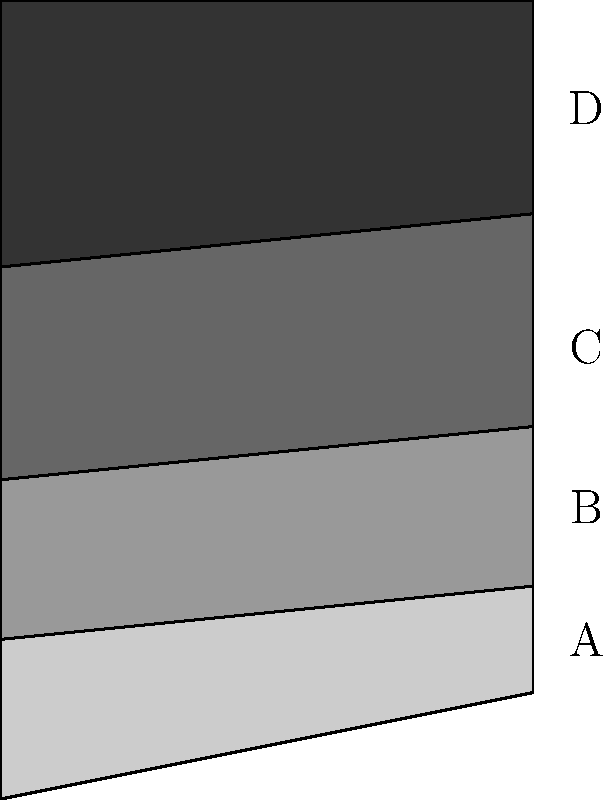In the geological cross-section shown above, which rock layer is likely to be the oldest, assuming no major tectonic disturbances have occurred? To determine the oldest rock layer in a geological cross-section, we need to apply the principle of superposition, which states that in undisturbed sedimentary rock sequences, the oldest layers are at the bottom and the youngest at the top. This principle is fundamental in stratigraphy and is based on the idea that sediments are deposited in a time sequence, with the oldest on the bottom and the youngest on top.

Let's analyze the cross-section step by step:

1. We can see four distinct layers labeled A, B, C, and D from top to bottom.
2. The layers appear to be relatively horizontal and undisturbed, suggesting no major tectonic activities have altered their original deposition order.
3. Following the principle of superposition, we start from the bottom:
   - Layer D is at the bottom of the sequence
   - Layer C is above D
   - Layer B is above C
   - Layer A is at the top

4. Since layer D is at the bottom of the sequence and there's no evidence of overturning or other structural complications, it is likely to be the oldest layer.

It's important to note that while this principle generally holds true for sedimentary rocks in undisturbed sequences, there can be exceptions in cases of thrust faults, overturned folds, or intrusive igneous bodies. However, the question specifies that no major tectonic disturbances have occurred, so we can confidently apply the principle of superposition here.
Answer: Layer D 